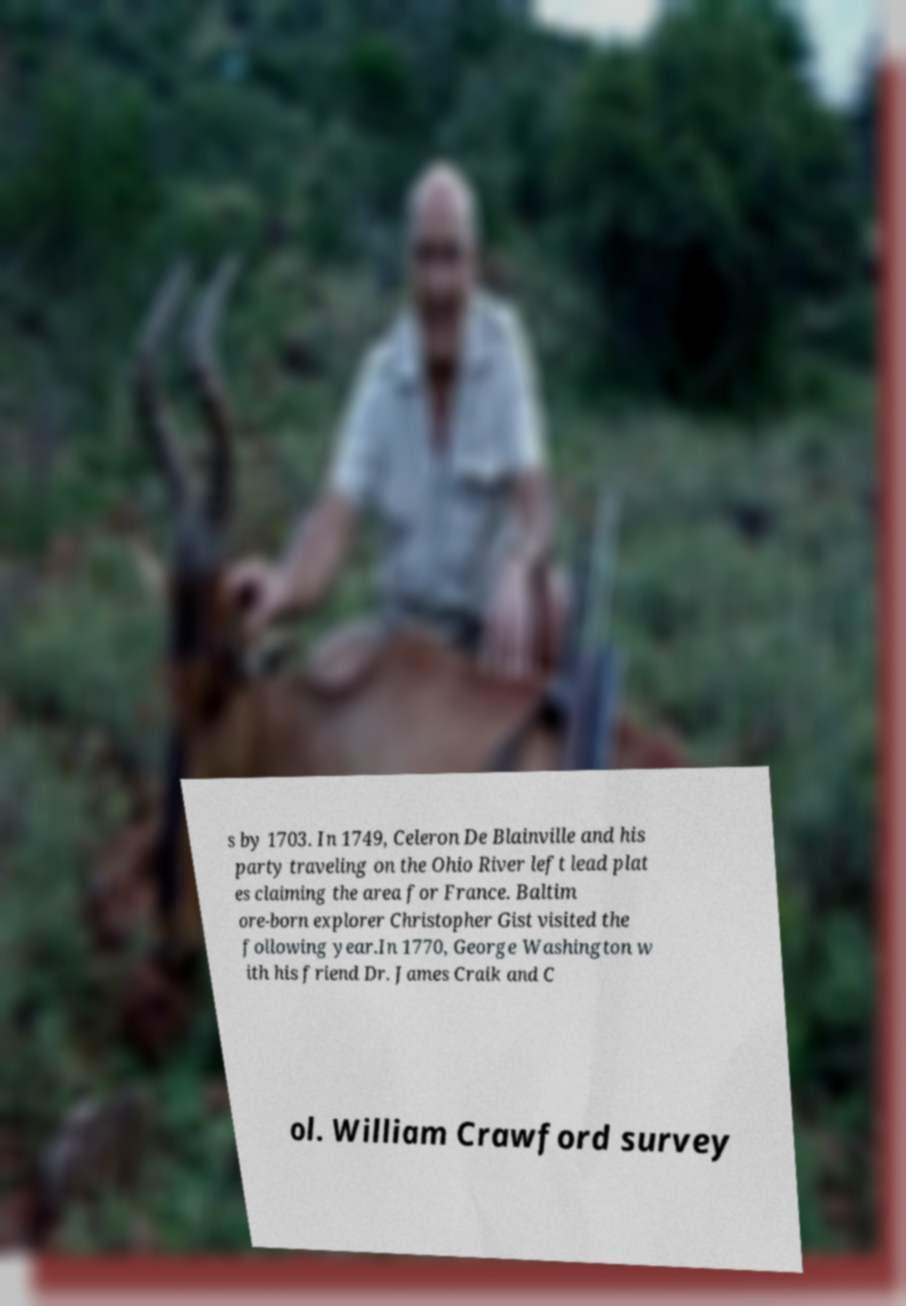For documentation purposes, I need the text within this image transcribed. Could you provide that? s by 1703. In 1749, Celeron De Blainville and his party traveling on the Ohio River left lead plat es claiming the area for France. Baltim ore-born explorer Christopher Gist visited the following year.In 1770, George Washington w ith his friend Dr. James Craik and C ol. William Crawford survey 